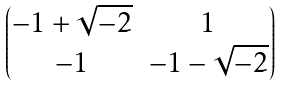Convert formula to latex. <formula><loc_0><loc_0><loc_500><loc_500>\begin{pmatrix} - 1 + \sqrt { - 2 } & 1 \\ - 1 & - 1 - \sqrt { - 2 } \end{pmatrix}</formula> 